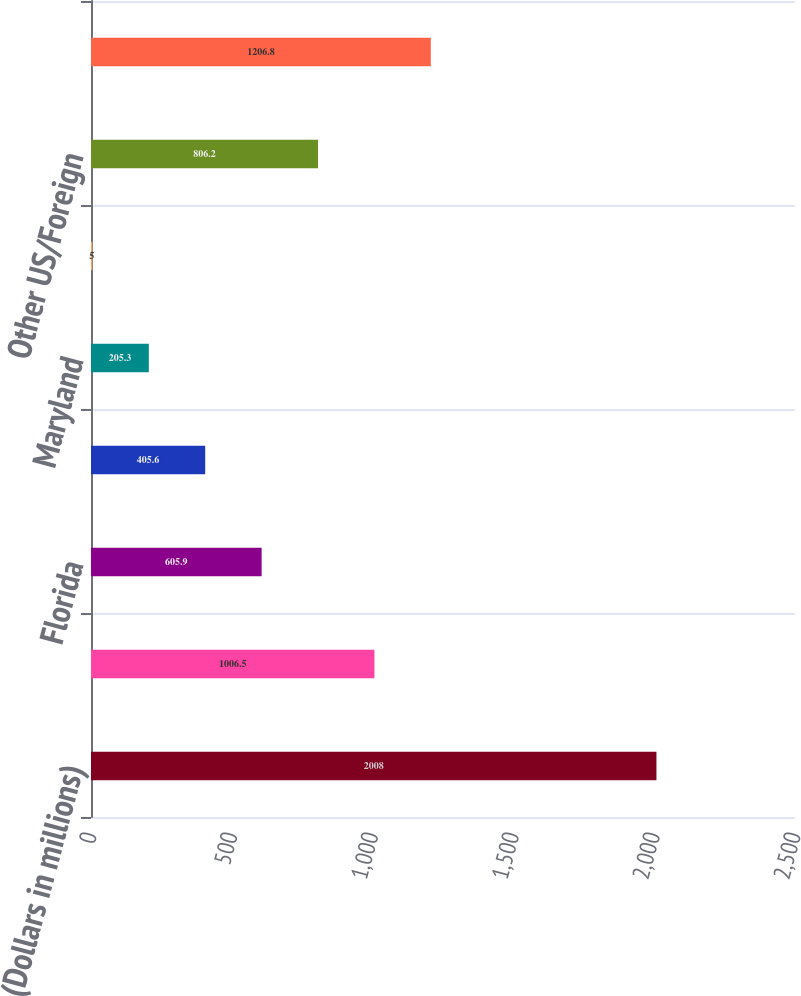<chart> <loc_0><loc_0><loc_500><loc_500><bar_chart><fcel>(Dollars in millions)<fcel>California<fcel>Florida<fcel>Virginia<fcel>Maryland<fcel>Texas<fcel>Other US/Foreign<fcel>Total Countrywide purchased<nl><fcel>2008<fcel>1006.5<fcel>605.9<fcel>405.6<fcel>205.3<fcel>5<fcel>806.2<fcel>1206.8<nl></chart> 